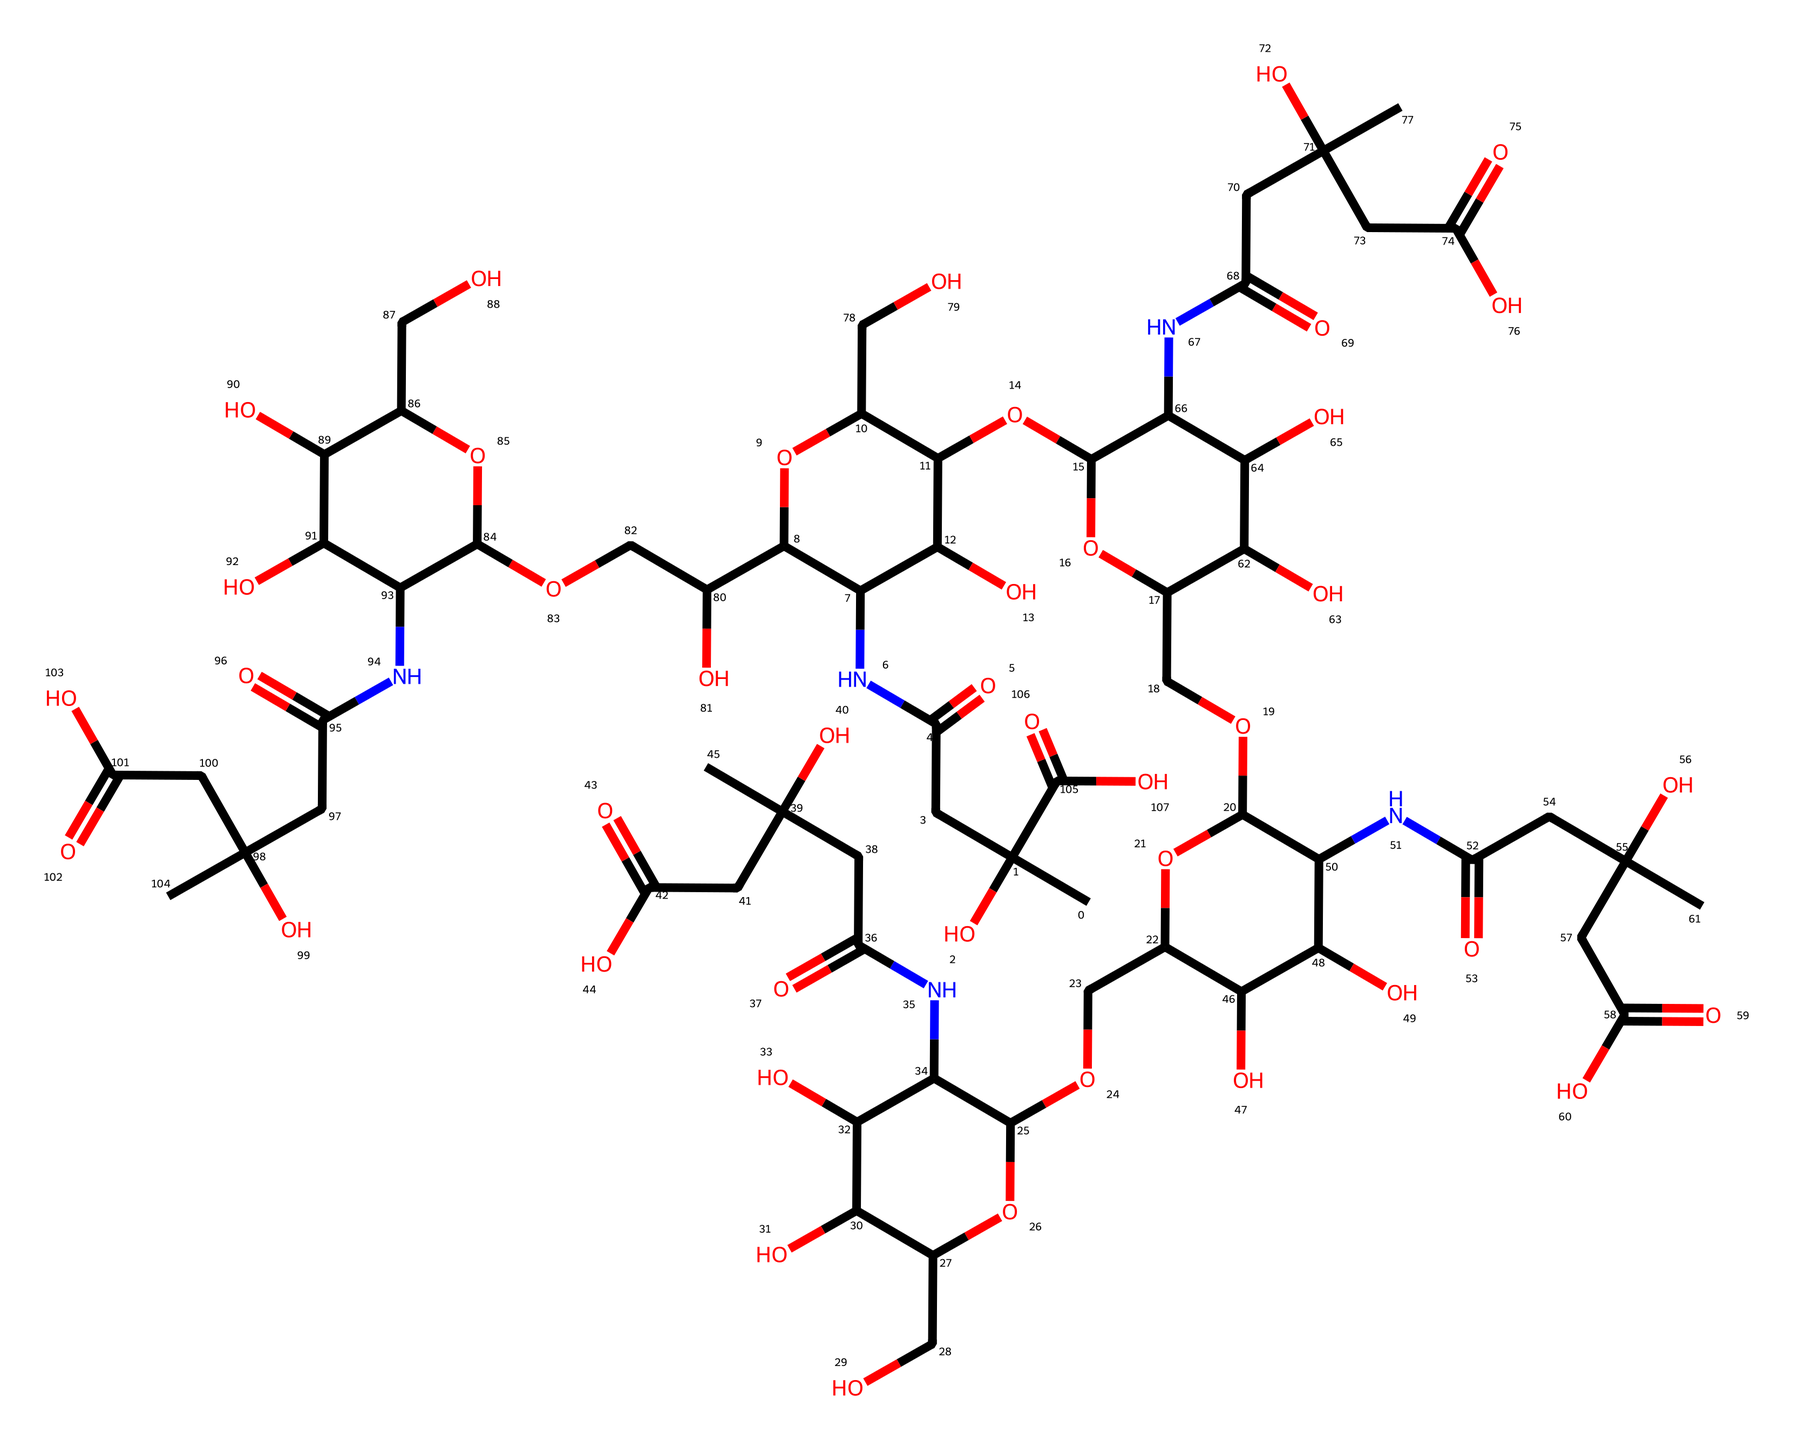What is the molecular formula of hyaluronic acid? By analyzing the SMILES representation, you can derive the molecular formula by counting the number of carbon (C), hydrogen (H), nitrogen (N), and oxygen (O) atoms present in the structure. From the SMILES, the count reveals that there are 42 carbon atoms, 66 hydrogen atoms, 6 oxygen atoms, and 4 nitrogen atoms, giving the final formula of C42H66N4O6.
Answer: C42H66N4O6 How many rings are present in this structure? In the given SMILES, rings can be identified by the presence of numbers that indicate the start and end of cycles. By carefully following the connections designated by the numbered atoms, the structure reveals a total of 4 rings throughout.
Answer: 4 What property does the presence of multiple hydroxyl groups confer to hyaluronic acid? The multiple hydroxyl (–OH) groups present in the structure increase its hydrophilicity, leading to enhanced water retention properties. This means hyaluronic acid can attract and hold large amounts of moisture, which is beneficial in skincare products.
Answer: hydrophilicity Which functional groups are predominant in hyaluronic acid? By examining the structure detailed in the SMILES notation, one can identify functional groups such as amides and hydroxyls as predominant. The presence of –OH groups denotes alcohols, while the –C(=O)N– linkage indicates amide groups. The combination of these groups contributes to its functions as a moisturizer.
Answer: amides and hydroxyls What role does the nitrogen atom play in hyaluronic acid? The nitrogen atom within the structure signifies the presence of amide functional groups. These groups are integral in maintaining the stability and flexibility of the polymer chain of hyaluronic acid, which ultimately enhances its performance in skincare applications through improved texture and moisture retention.
Answer: amide stability How does the presence of acyl groups influence the functionality of hyaluronic acid? Acyl groups, which are represented in the structure by –C(=O)– functional moieties, contribute significantly to the solubility and reactivity of hyaluronic acid. They help in forming hydrogen bonds with water, thereby increasing hydration ability, making it effective in moisturizing formulations.
Answer: increased hydration ability 